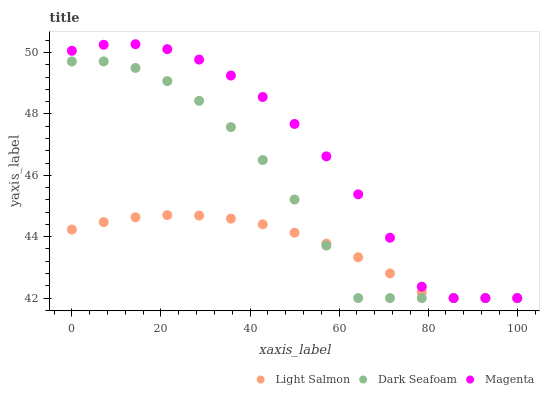Does Light Salmon have the minimum area under the curve?
Answer yes or no. Yes. Does Magenta have the maximum area under the curve?
Answer yes or no. Yes. Does Dark Seafoam have the minimum area under the curve?
Answer yes or no. No. Does Dark Seafoam have the maximum area under the curve?
Answer yes or no. No. Is Light Salmon the smoothest?
Answer yes or no. Yes. Is Dark Seafoam the roughest?
Answer yes or no. Yes. Is Magenta the smoothest?
Answer yes or no. No. Is Magenta the roughest?
Answer yes or no. No. Does Light Salmon have the lowest value?
Answer yes or no. Yes. Does Magenta have the highest value?
Answer yes or no. Yes. Does Dark Seafoam have the highest value?
Answer yes or no. No. Does Magenta intersect Light Salmon?
Answer yes or no. Yes. Is Magenta less than Light Salmon?
Answer yes or no. No. Is Magenta greater than Light Salmon?
Answer yes or no. No. 